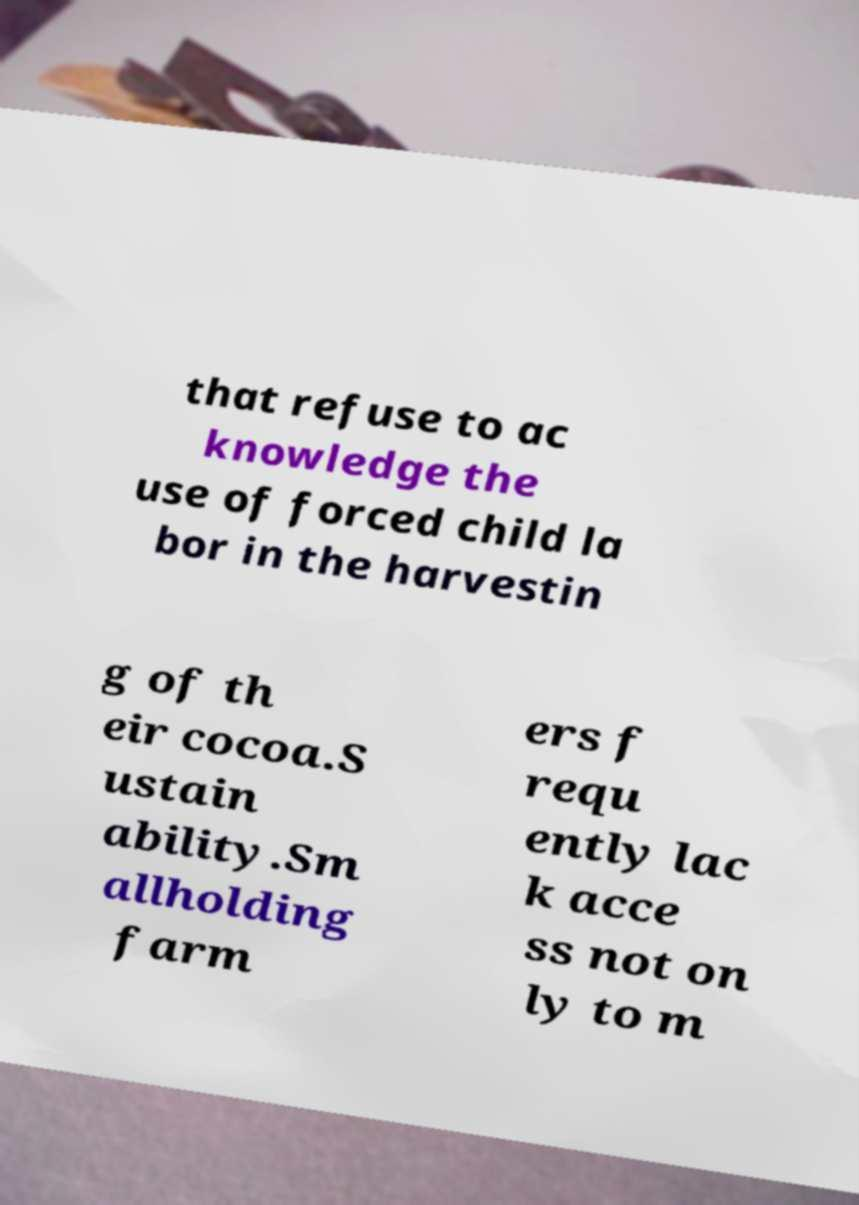I need the written content from this picture converted into text. Can you do that? that refuse to ac knowledge the use of forced child la bor in the harvestin g of th eir cocoa.S ustain ability.Sm allholding farm ers f requ ently lac k acce ss not on ly to m 